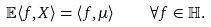Convert formula to latex. <formula><loc_0><loc_0><loc_500><loc_500>\mathbb { E } \langle { f } , { X } \rangle = \langle { f } , { \mu } \rangle \quad \forall f \in \mathbb { H } .</formula> 